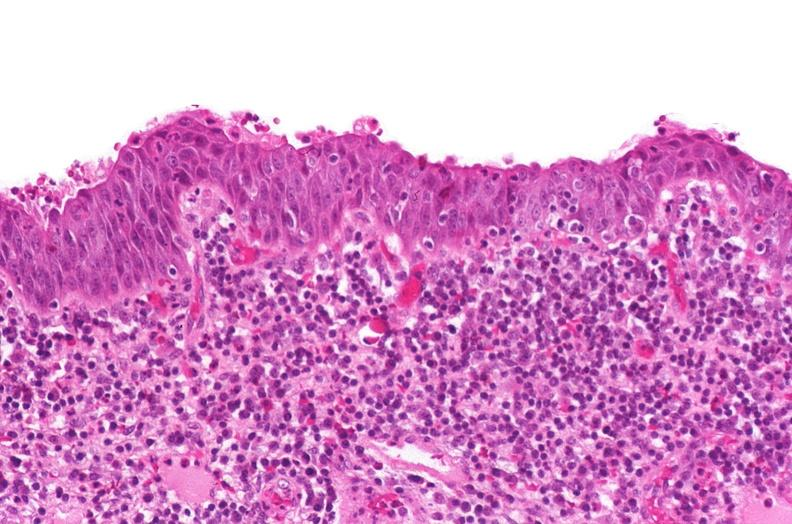why does this image show renal pelvis, squamous metaplasia?
Answer the question using a single word or phrase. Due to chronic urolithiasis 